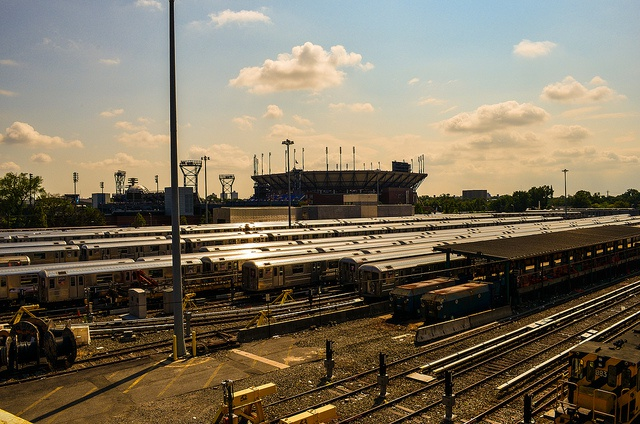Describe the objects in this image and their specific colors. I can see train in gray, black, maroon, and olive tones, train in gray, black, and tan tones, train in gray, black, maroon, darkgray, and tan tones, train in gray, black, tan, and maroon tones, and train in gray, black, maroon, and tan tones in this image. 